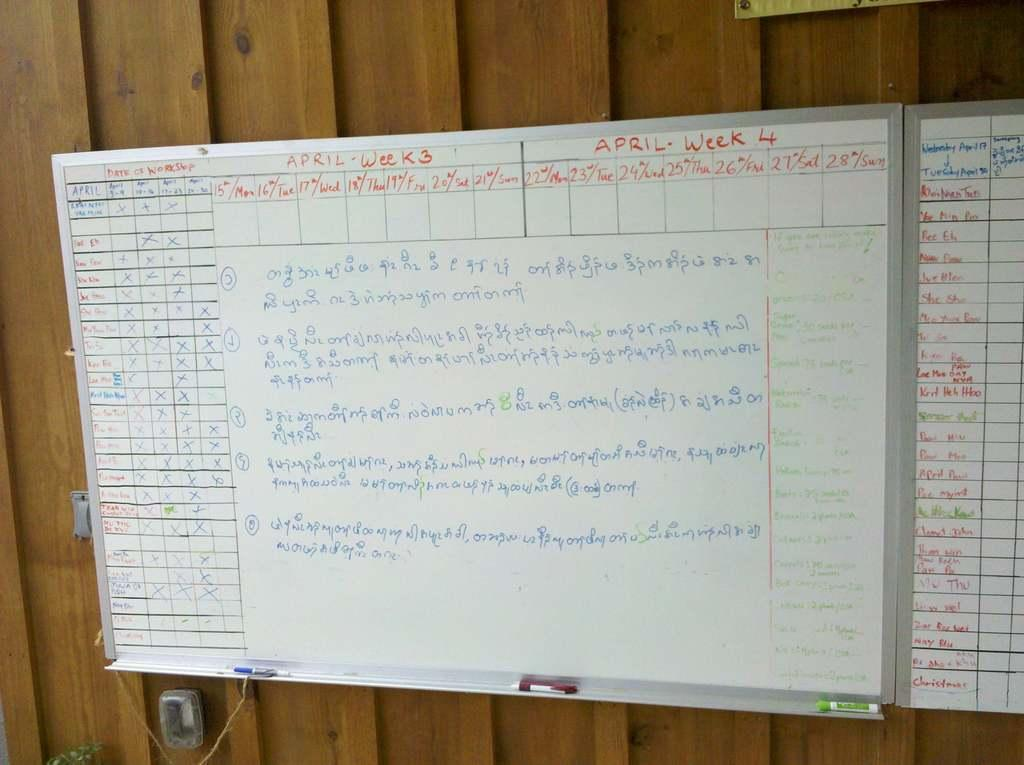What type of boards are on the wall in the image? There are white boards on the wall in the image. What can be seen on the white boards? There is text visible on the white boards. What material is the wall made of? The wall is made of wood. What type of story is being told on the white boards? There is no story being told on the white boards; they contain text, but it is not specified as a story. 